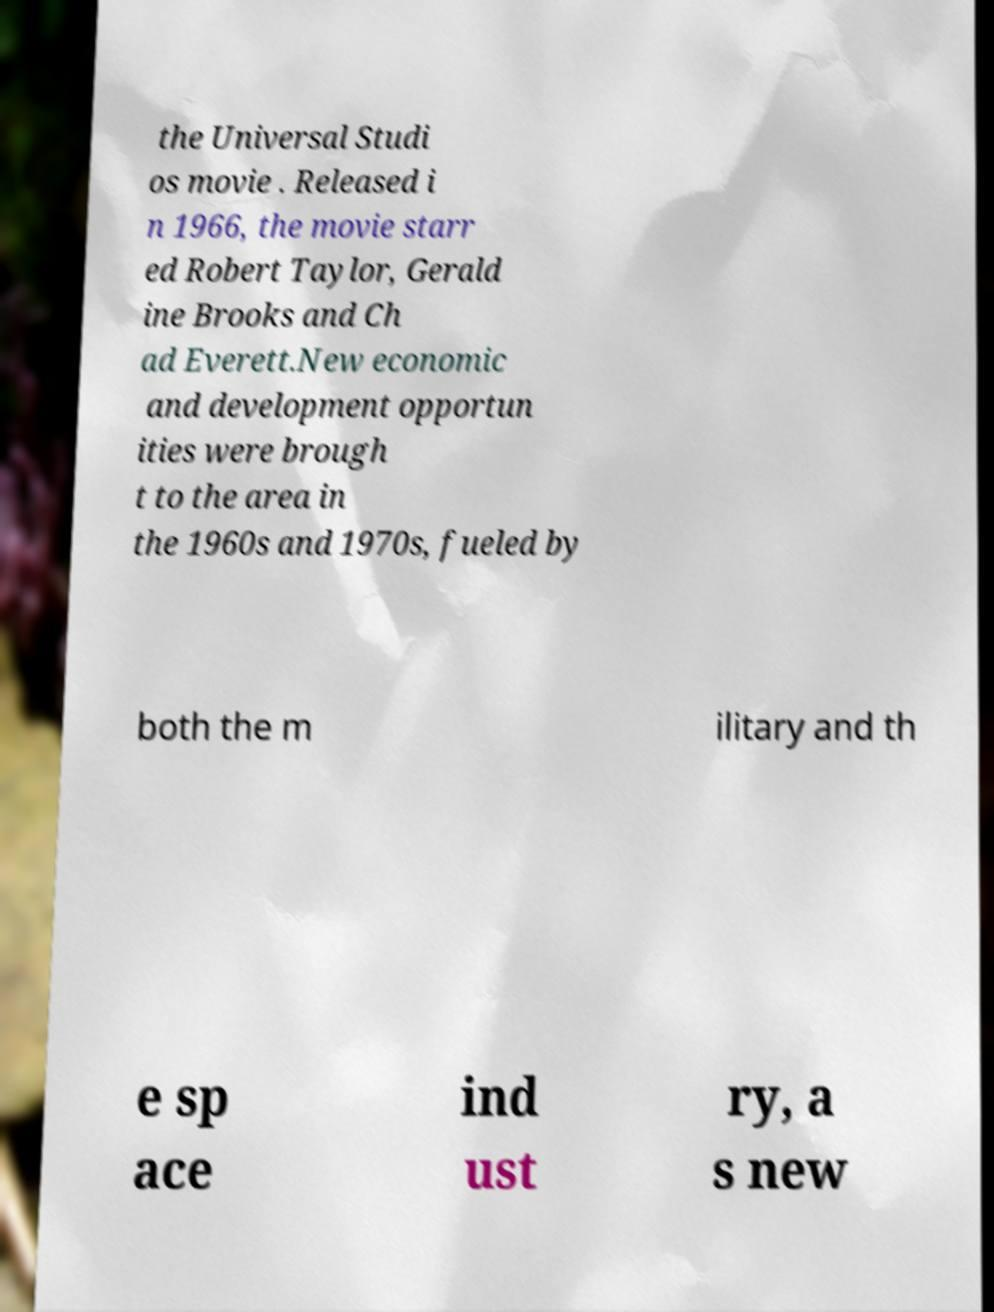Can you accurately transcribe the text from the provided image for me? the Universal Studi os movie . Released i n 1966, the movie starr ed Robert Taylor, Gerald ine Brooks and Ch ad Everett.New economic and development opportun ities were brough t to the area in the 1960s and 1970s, fueled by both the m ilitary and th e sp ace ind ust ry, a s new 